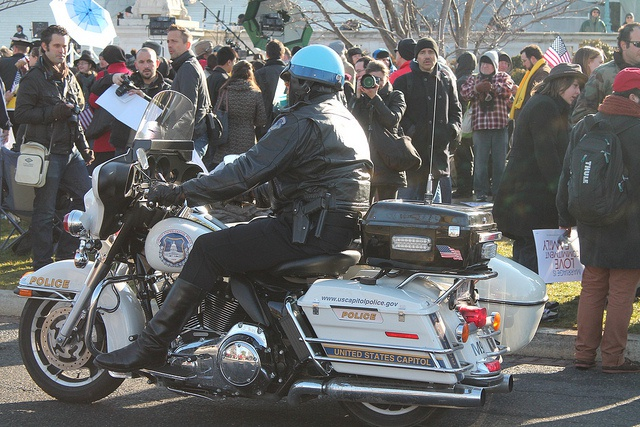Describe the objects in this image and their specific colors. I can see motorcycle in lightblue, black, gray, and darkgray tones, people in lightblue, black, gray, white, and purple tones, people in lightblue, gray, and black tones, people in lightblue, black, gray, and purple tones, and people in lightblue, black, and gray tones in this image. 